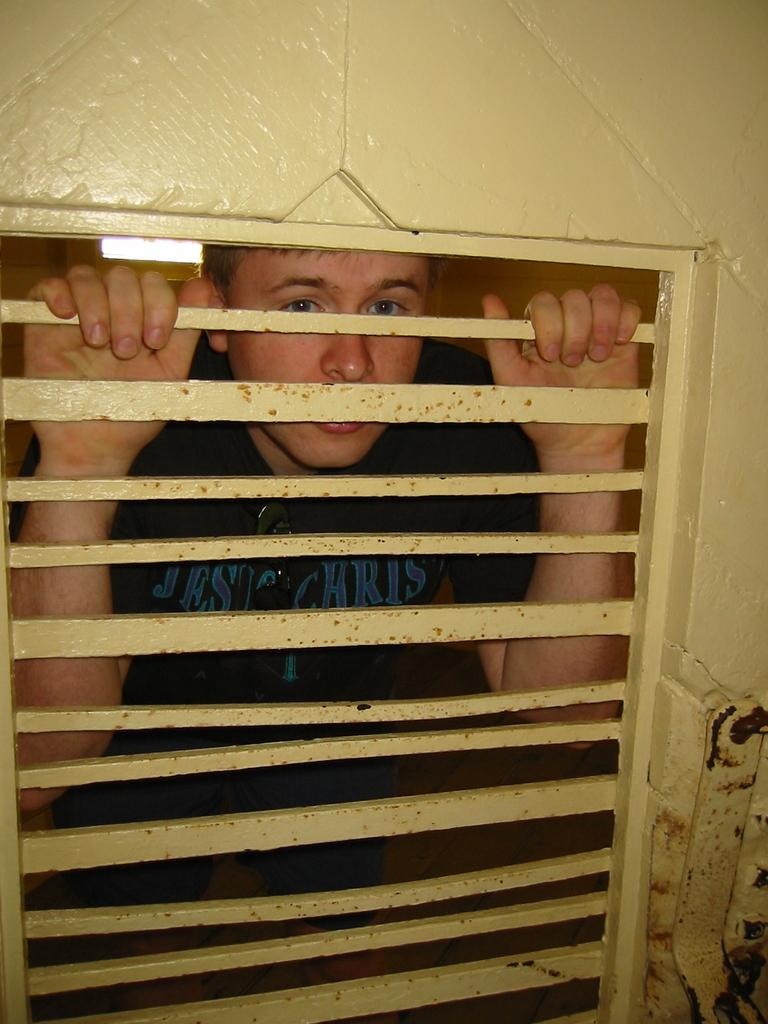What is the main feature of the wall in the image? There is a wall with grills in the image. What is the man in the image doing with the grills? A man is holding the grills in the image. What type of test is the man conducting with the grills in the image? There is no indication in the image that the man is conducting a test with the grills. Can you see any pickles in the image? There are no pickles present in the image. 